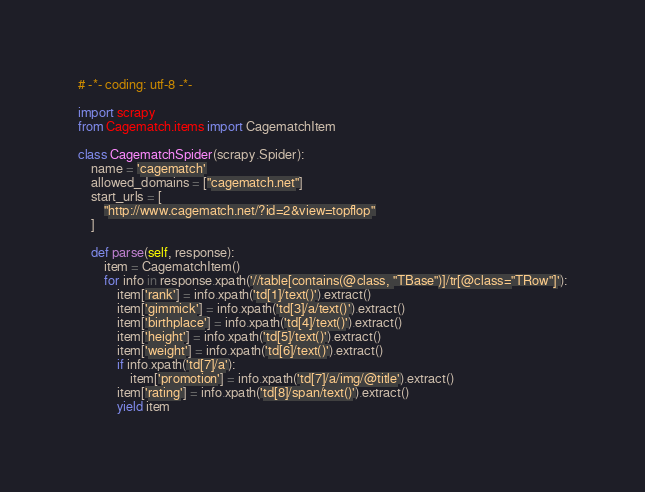<code> <loc_0><loc_0><loc_500><loc_500><_Python_># -*- coding: utf-8 -*-

import scrapy
from Cagematch.items import CagematchItem

class CagematchSpider(scrapy.Spider):
	name = 'cagematch'
	allowed_domains = ["cagematch.net"]
	start_urls = [
		"http://www.cagematch.net/?id=2&view=topflop"
	]

	def parse(self, response):
		item = CagematchItem()
		for info in response.xpath('//table[contains(@class, "TBase")]/tr[@class="TRow"]'):
			item['rank'] = info.xpath('td[1]/text()').extract()
			item['gimmick'] = info.xpath('td[3]/a/text()').extract()
			item['birthplace'] = info.xpath('td[4]/text()').extract()
			item['height'] = info.xpath('td[5]/text()').extract()
			item['weight'] = info.xpath('td[6]/text()').extract()
			if info.xpath('td[7]/a'):
				item['promotion'] = info.xpath('td[7]/a/img/@title').extract()
			item['rating'] = info.xpath('td[8]/span/text()').extract()
			yield item</code> 